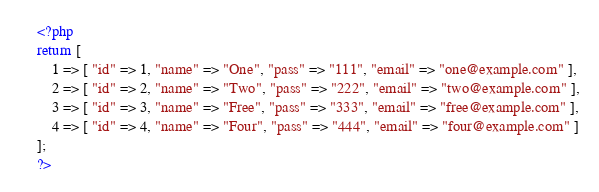<code> <loc_0><loc_0><loc_500><loc_500><_PHP_><?php
return [
	1 => [ "id" => 1, "name" => "One", "pass" => "111", "email" => "one@example.com" ],
	2 => [ "id" => 2, "name" => "Two", "pass" => "222", "email" => "two@example.com" ],
	3 => [ "id" => 3, "name" => "Free", "pass" => "333", "email" => "free@example.com" ],
	4 => [ "id" => 4, "name" => "Four", "pass" => "444", "email" => "four@example.com" ]
];
?></code> 